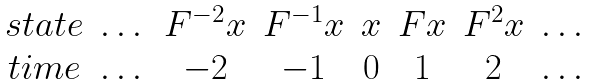<formula> <loc_0><loc_0><loc_500><loc_500>\begin{matrix} s t a t e & \dots & F ^ { - 2 } x & F ^ { - 1 } x & x & F x & F ^ { 2 } x & \dots \\ t i m e & \dots & - 2 & - 1 & 0 & 1 & 2 & \dots \end{matrix}</formula> 